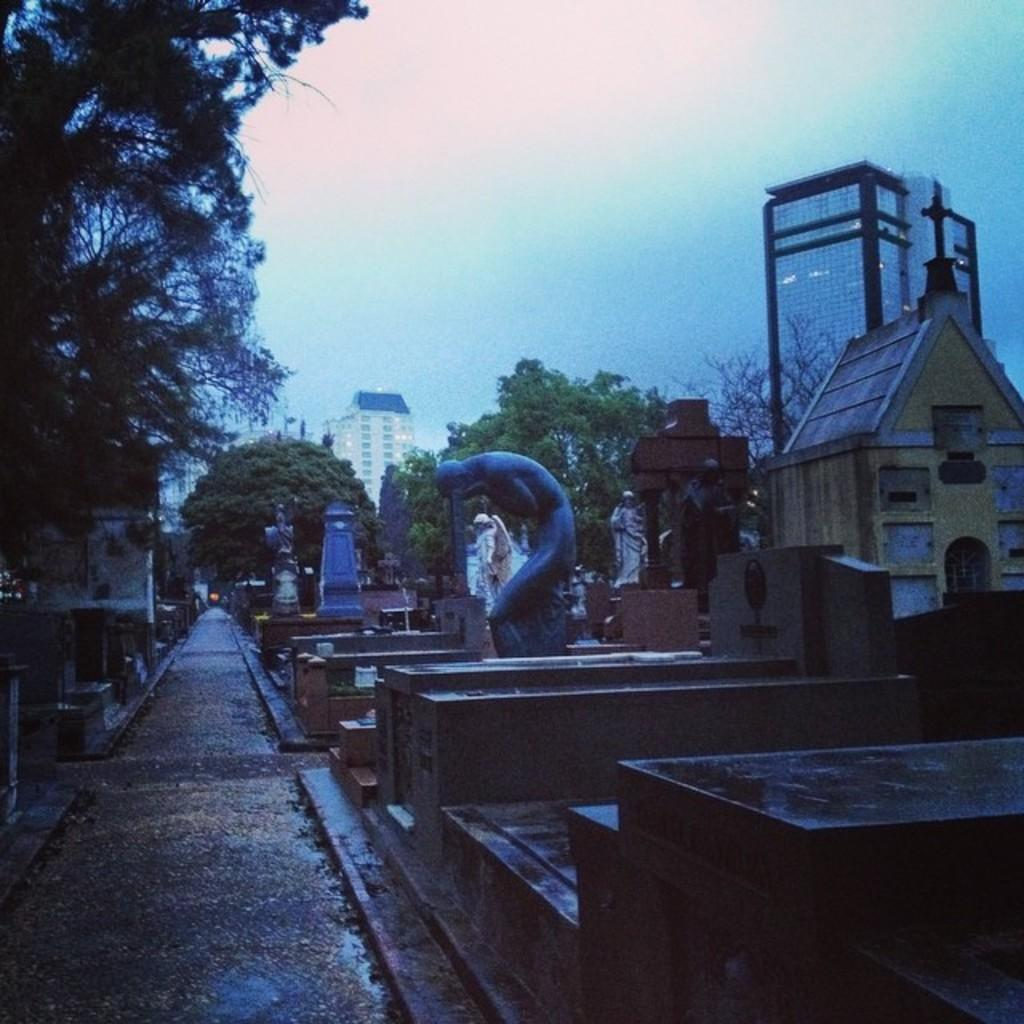What type of objects can be seen in the image? There are statues and other structures in the image. What can be seen in the background of the image? There are trees and buildings in the background of the image. What is visible at the top of the image? The sky is visible at the top of the image. How many pairs of shoes are visible in the image? There are no shoes present in the image. Can you describe the color of the kittens in the image? There are no kittens present in the image. 